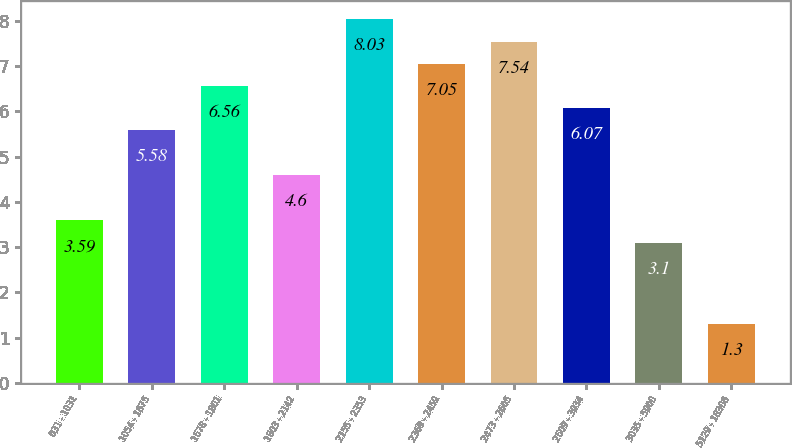<chart> <loc_0><loc_0><loc_500><loc_500><bar_chart><fcel>031 - 1031<fcel>1054 - 1675<fcel>1678 - 1801<fcel>1803 - 2142<fcel>2155 - 2353<fcel>2369 - 2459<fcel>2473 - 2605<fcel>2609 - 3034<fcel>3035 - 5000<fcel>5129 - 18306<nl><fcel>3.59<fcel>5.58<fcel>6.56<fcel>4.6<fcel>8.03<fcel>7.05<fcel>7.54<fcel>6.07<fcel>3.1<fcel>1.3<nl></chart> 